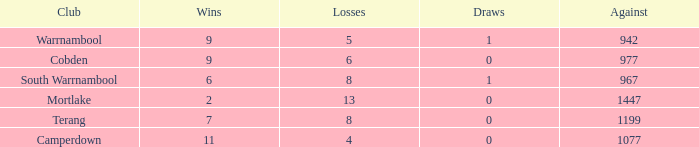What is the draw when the losses were more than 8 and less than 2 wins? None. 